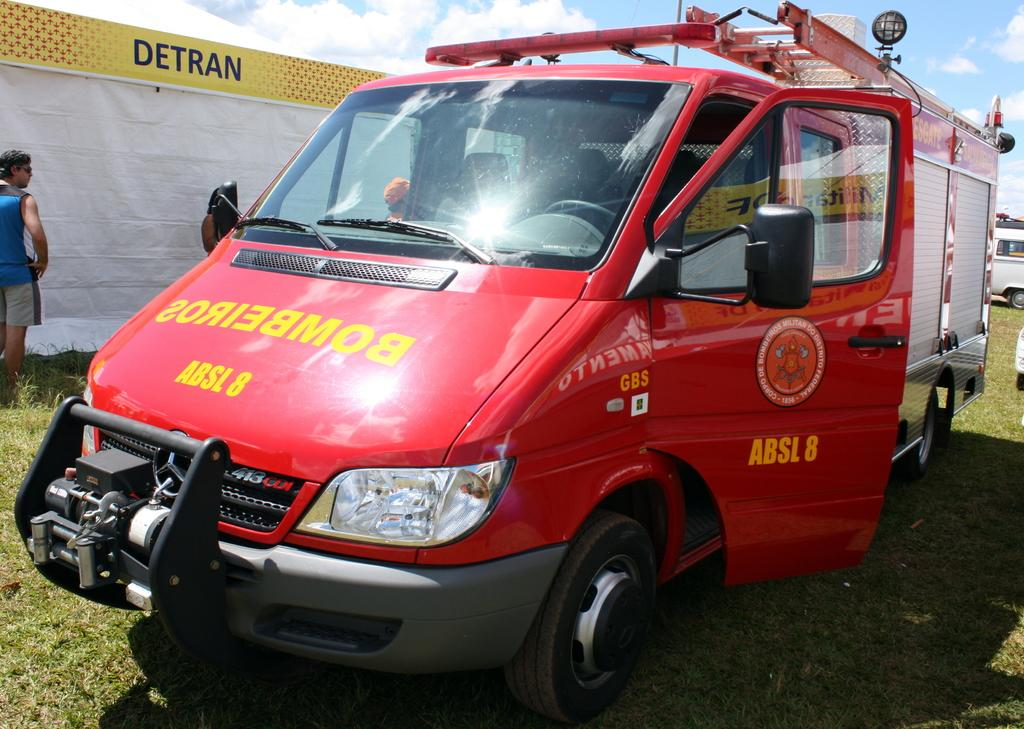<image>
Give a short and clear explanation of the subsequent image. Red truck which says ABSL 8 in yellow words. 